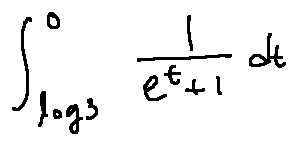<formula> <loc_0><loc_0><loc_500><loc_500>\int \lim i t s _ { \log 3 } ^ { 0 } \frac { 1 } { e ^ { t } + 1 } d t</formula> 